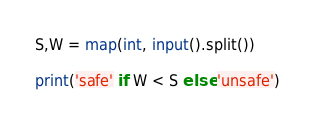<code> <loc_0><loc_0><loc_500><loc_500><_Python_>S,W = map(int, input().split())

print('safe' if W < S else 'unsafe')</code> 